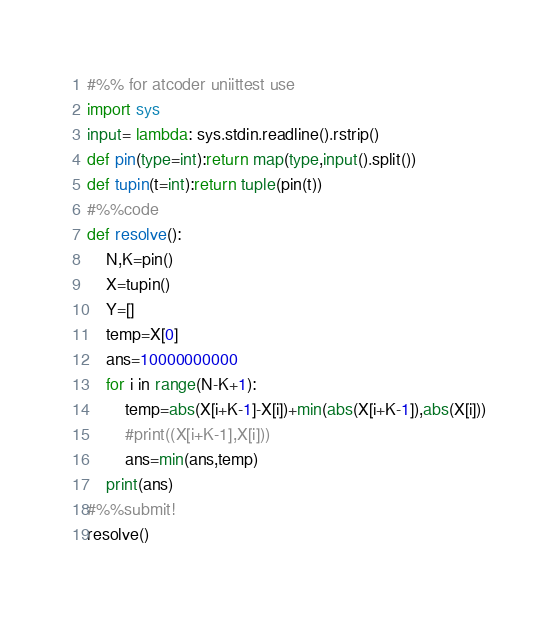<code> <loc_0><loc_0><loc_500><loc_500><_Python_>#%% for atcoder uniittest use
import sys
input= lambda: sys.stdin.readline().rstrip()
def pin(type=int):return map(type,input().split())
def tupin(t=int):return tuple(pin(t))
#%%code
def resolve():
    N,K=pin()
    X=tupin()
    Y=[]
    temp=X[0]
    ans=10000000000
    for i in range(N-K+1):
        temp=abs(X[i+K-1]-X[i])+min(abs(X[i+K-1]),abs(X[i]))
        #print((X[i+K-1],X[i]))
        ans=min(ans,temp)
    print(ans)    
#%%submit!
resolve()</code> 